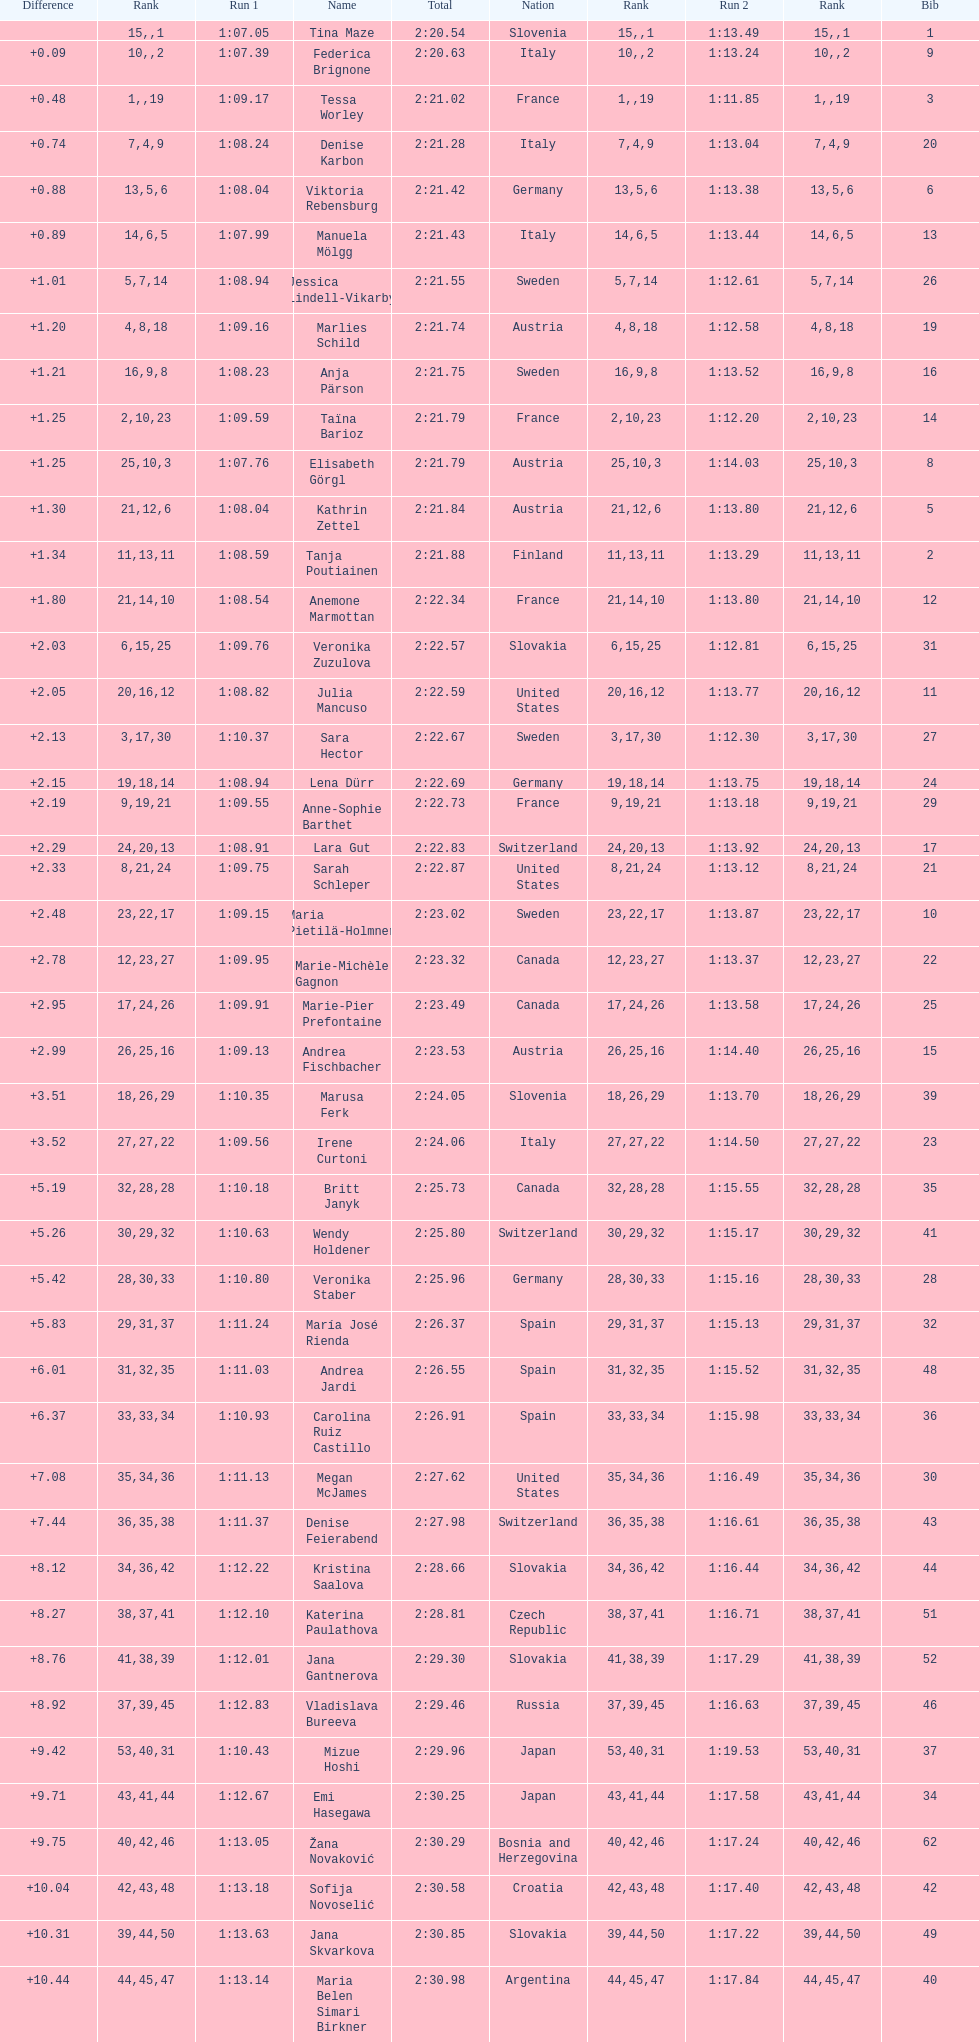Who ranked next after federica brignone? Tessa Worley. 